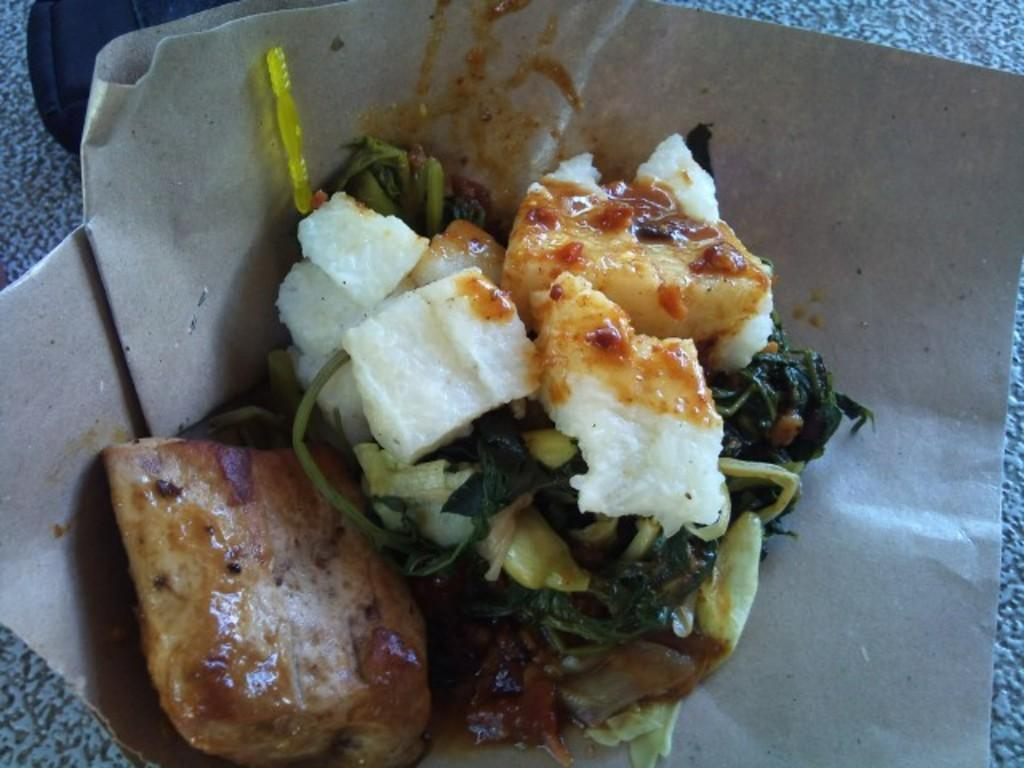What is present on the paper in the image? The facts provided do not specify any details about the paper in the image. What can be seen in the dish in the image? The facts provided do not specify any details about the dish in the image. What type of star can be seen teaching with a feather in the image? There is no star or feather present in the image. 